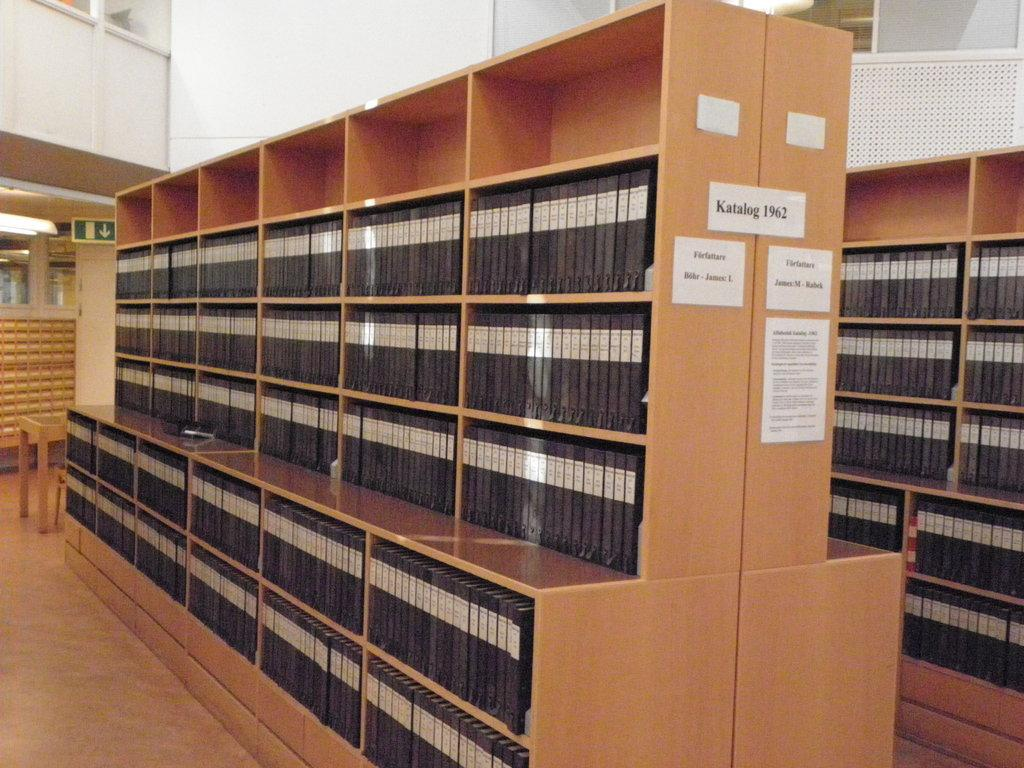<image>
Describe the image concisely. Library with a stack of books all with same color and size, Katalog 1962. 